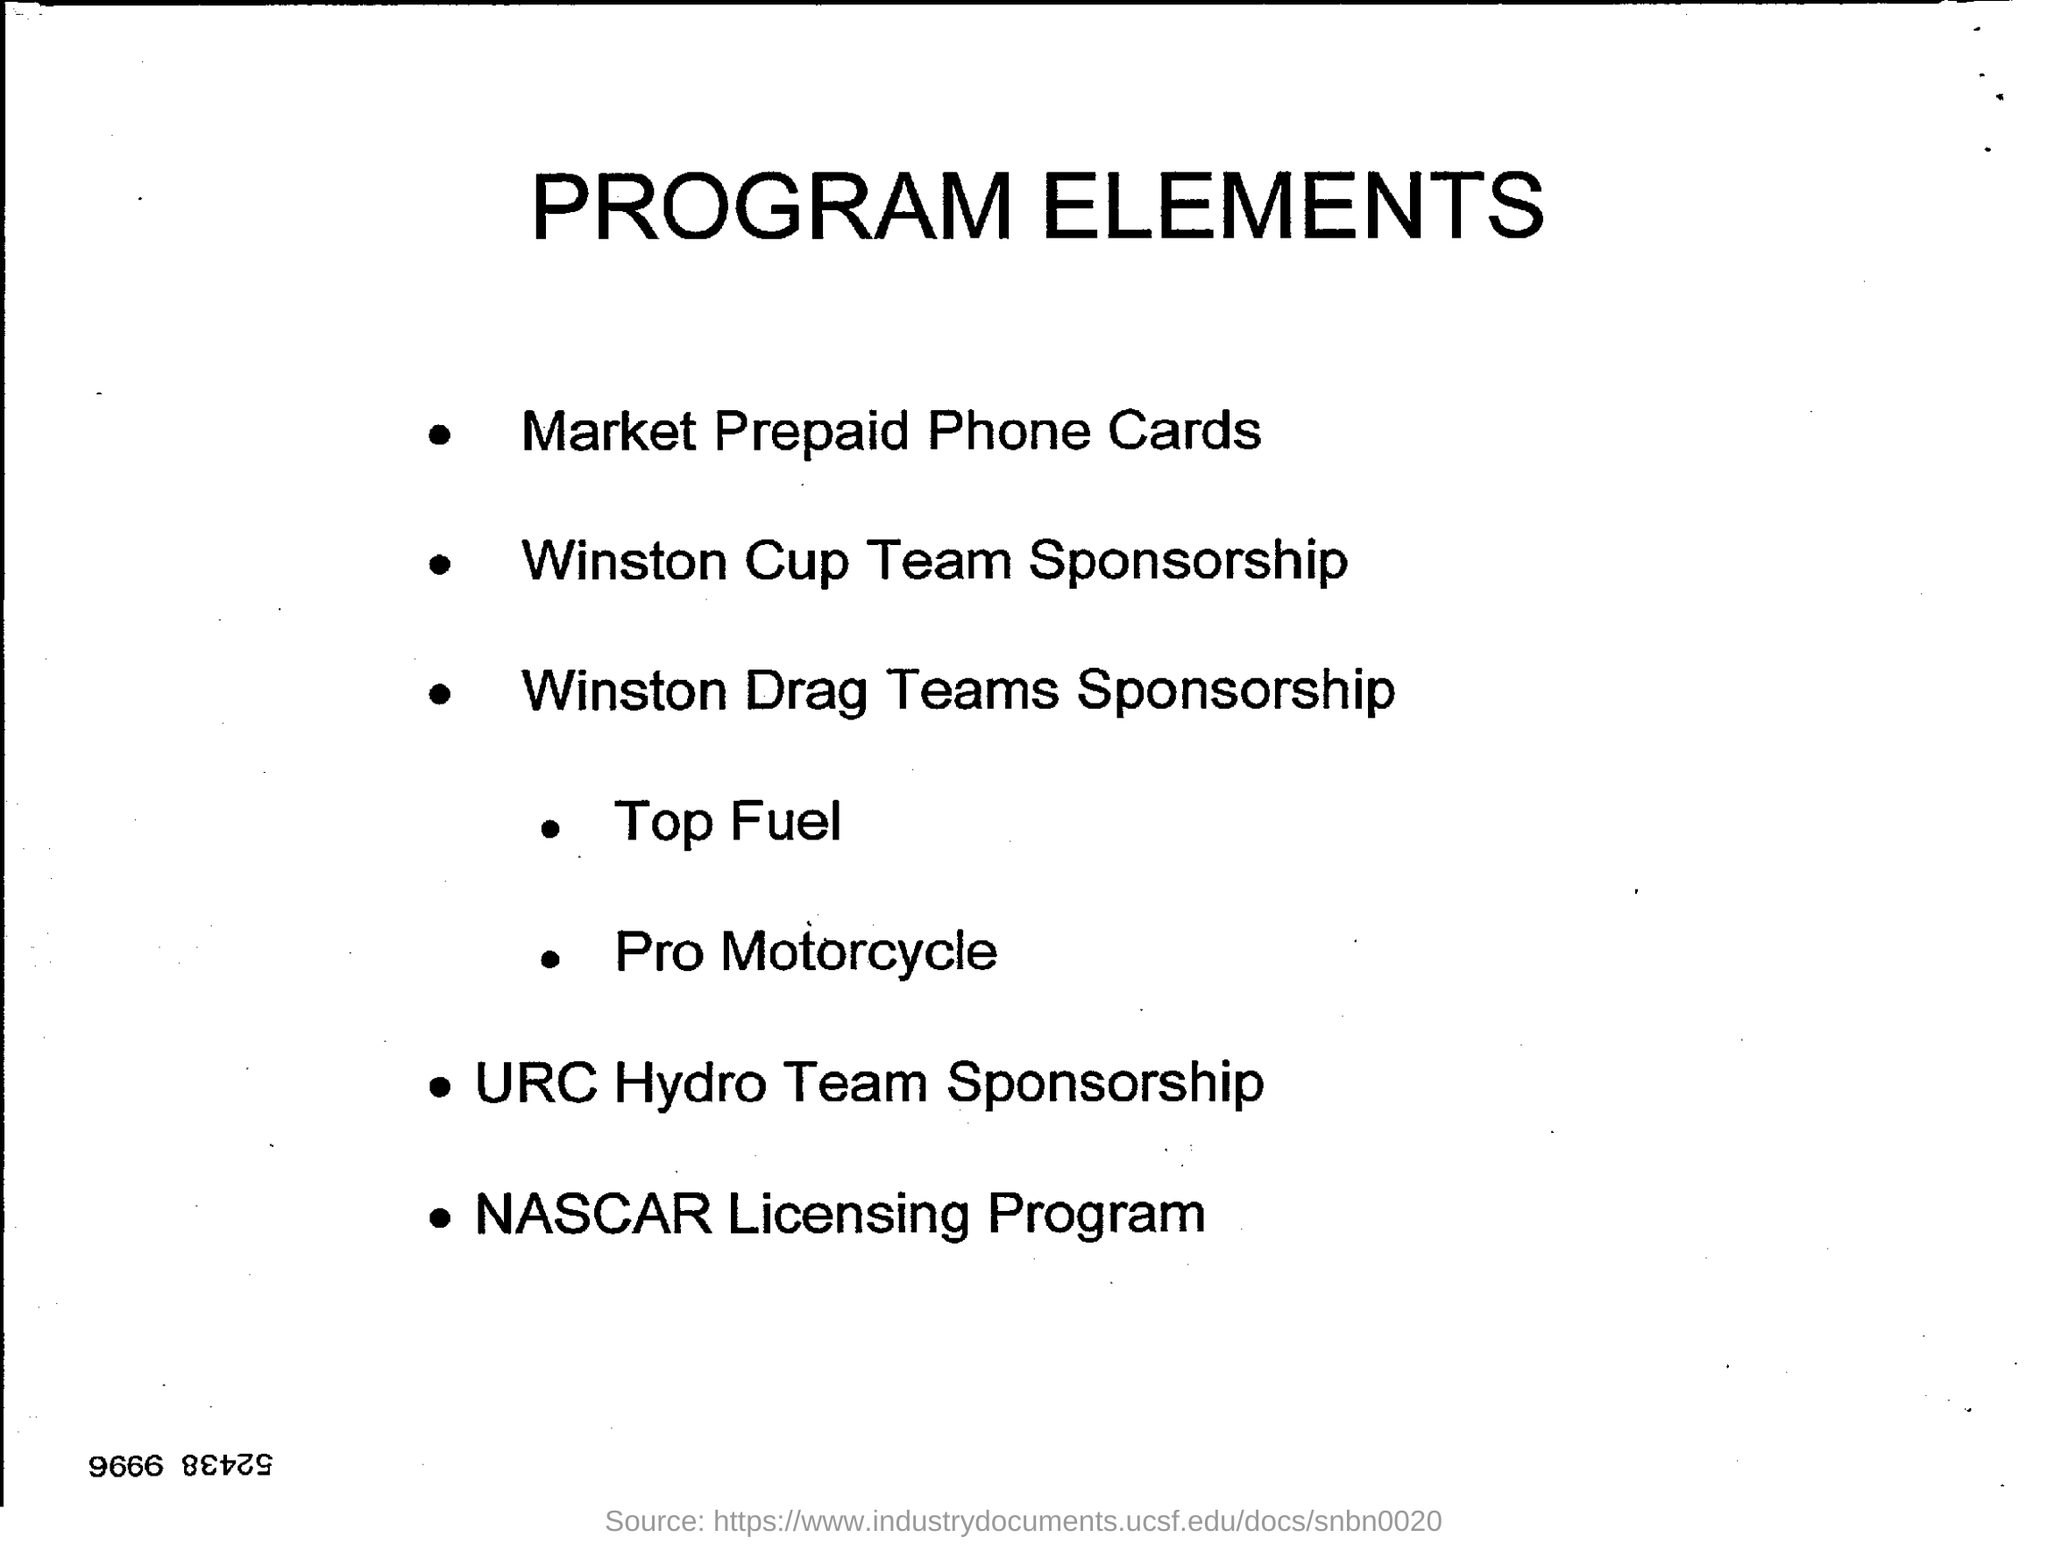Give some essential details in this illustration. The name of the licensing program is NASCAR. The heading of the document is 'PROGRAM ELEMENTS'. What is the first point? It is the market for prepaid phone cards. URC is a sponsorship for the URC Hydro Team. 